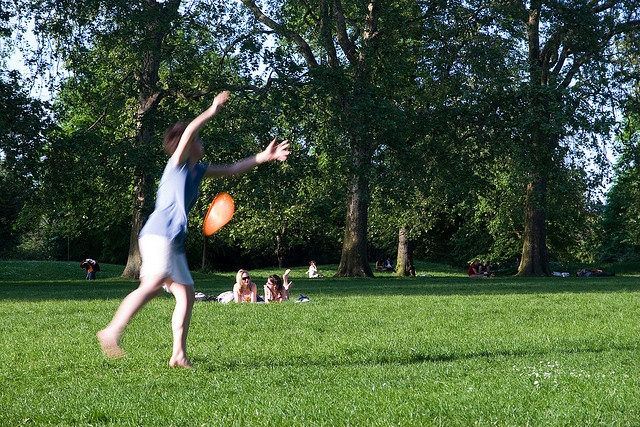Describe the objects in this image and their specific colors. I can see people in blue, lavender, black, gray, and darkgreen tones, frisbee in blue, ivory, tan, salmon, and red tones, people in blue, white, black, gray, and brown tones, people in blue, white, brown, lightpink, and maroon tones, and people in blue, black, navy, gray, and darkblue tones in this image. 